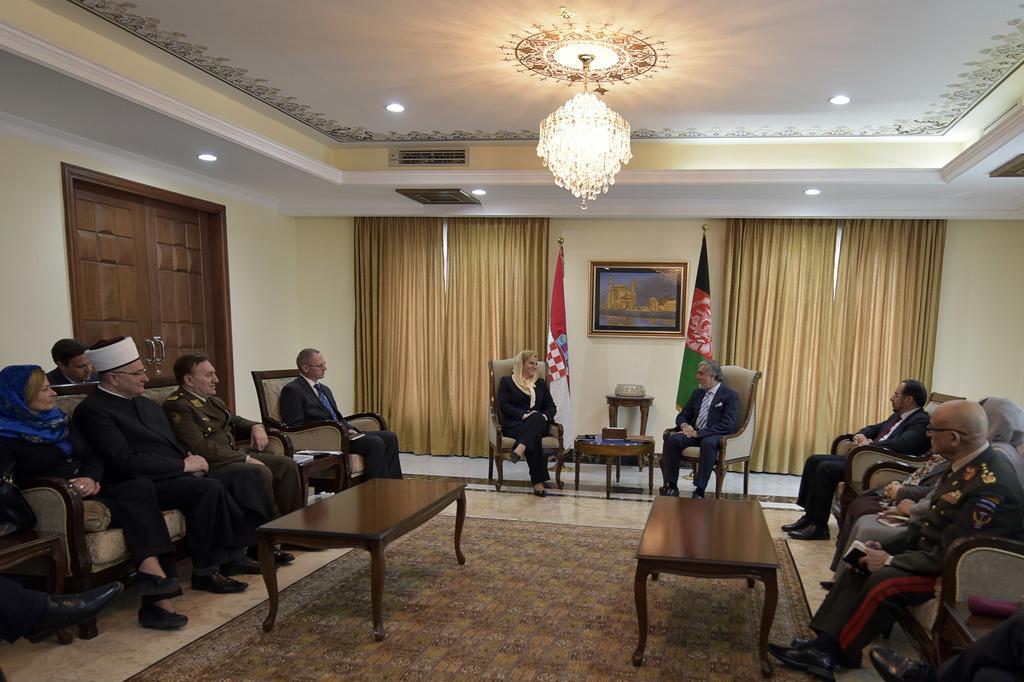Please provide a concise description of this image. In this picture to the left their group of people who are sitting on the chair. There is a woman and a man, both are sitting on the chair. To the right, there are three people who are sitting on the chair. There is a table and a carpet. There is a brown curtain. There are two flags. There is a frame on the wall. There is a chandelier to the roof. 